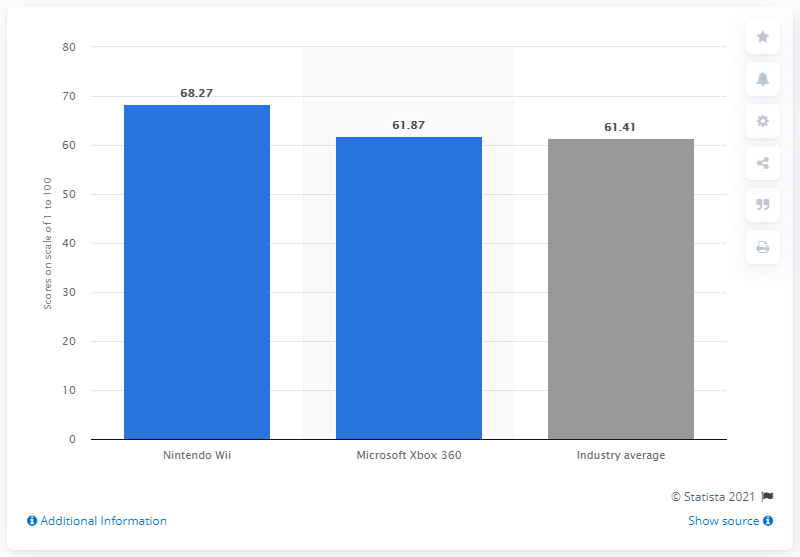Outline some significant characteristics in this image. In 2012, Nintendo's equity score was 68.27. 